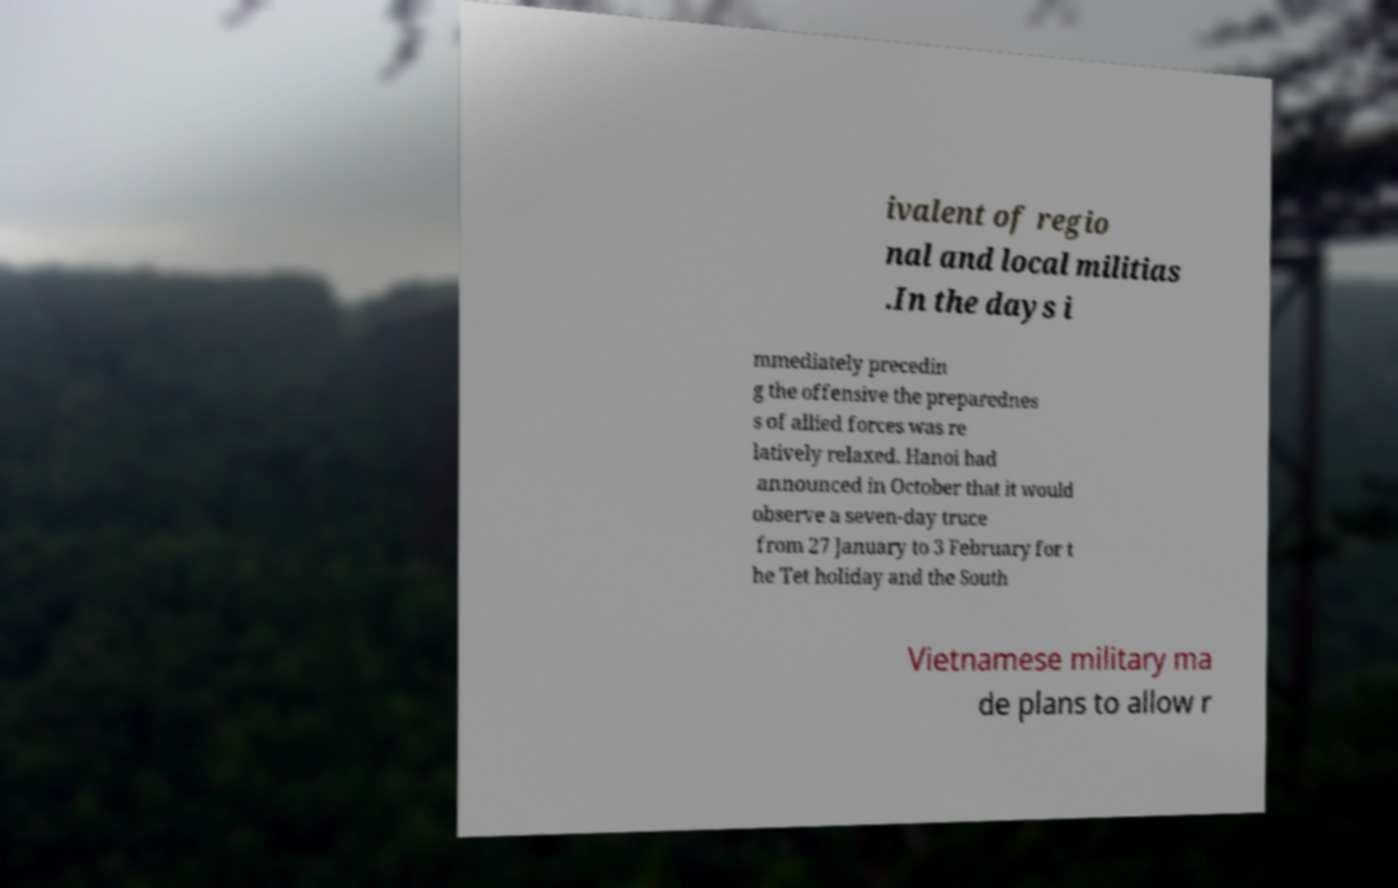Please identify and transcribe the text found in this image. ivalent of regio nal and local militias .In the days i mmediately precedin g the offensive the preparednes s of allied forces was re latively relaxed. Hanoi had announced in October that it would observe a seven-day truce from 27 January to 3 February for t he Tet holiday and the South Vietnamese military ma de plans to allow r 